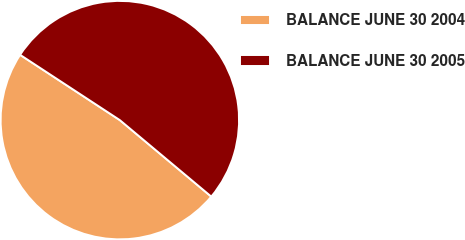Convert chart to OTSL. <chart><loc_0><loc_0><loc_500><loc_500><pie_chart><fcel>BALANCE JUNE 30 2004<fcel>BALANCE JUNE 30 2005<nl><fcel>48.14%<fcel>51.86%<nl></chart> 